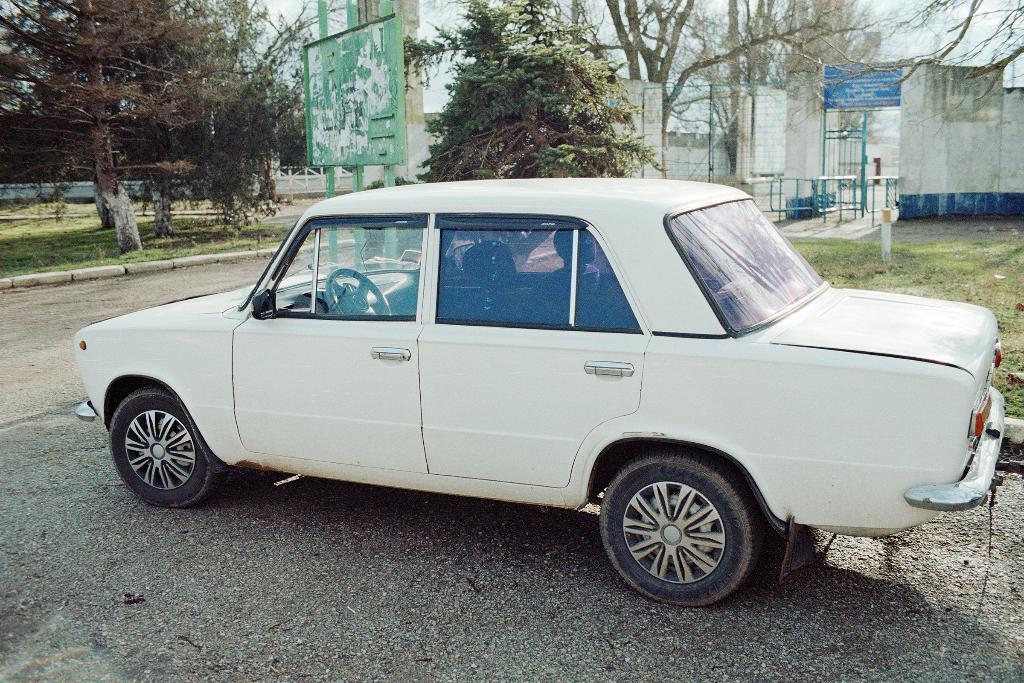Can you describe this image briefly? In this picture there is a white color car and there are trees and buildings in the background. 